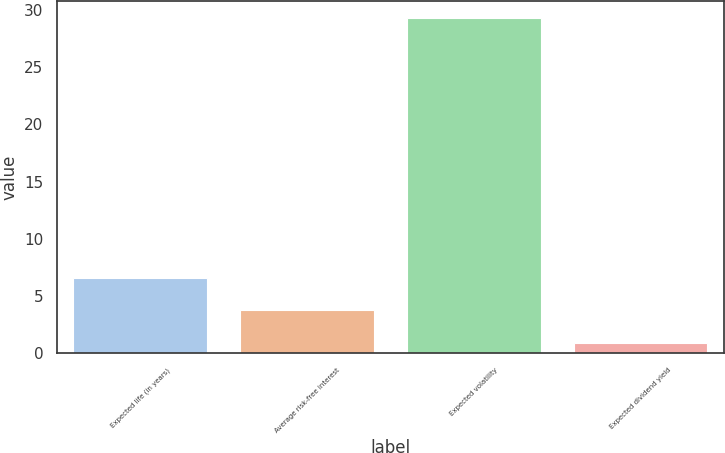Convert chart. <chart><loc_0><loc_0><loc_500><loc_500><bar_chart><fcel>Expected life (in years)<fcel>Average risk-free interest<fcel>Expected volatility<fcel>Expected dividend yield<nl><fcel>6.6<fcel>3.76<fcel>29.3<fcel>0.92<nl></chart> 